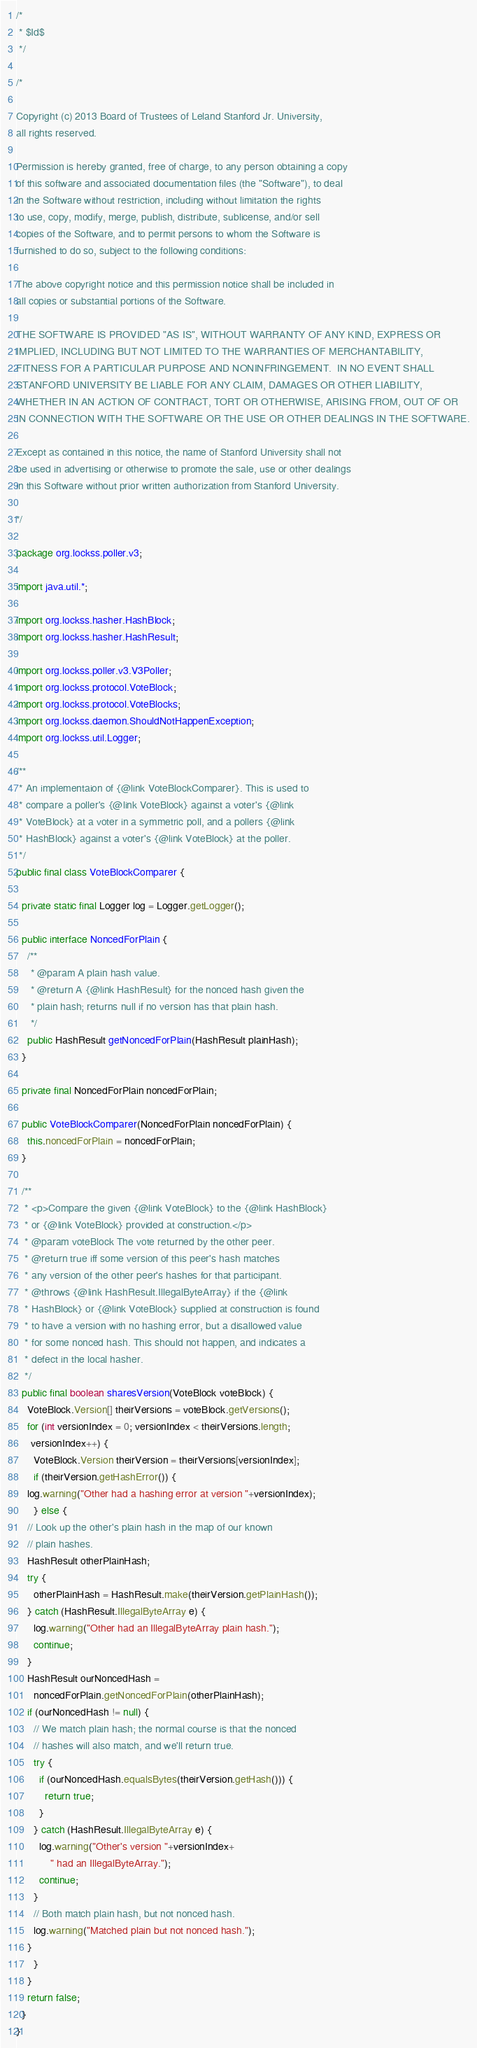<code> <loc_0><loc_0><loc_500><loc_500><_Java_>/*
 * $Id$
 */

/*

Copyright (c) 2013 Board of Trustees of Leland Stanford Jr. University,
all rights reserved.

Permission is hereby granted, free of charge, to any person obtaining a copy
of this software and associated documentation files (the "Software"), to deal
in the Software without restriction, including without limitation the rights
to use, copy, modify, merge, publish, distribute, sublicense, and/or sell
copies of the Software, and to permit persons to whom the Software is
furnished to do so, subject to the following conditions:

The above copyright notice and this permission notice shall be included in
all copies or substantial portions of the Software.

THE SOFTWARE IS PROVIDED "AS IS", WITHOUT WARRANTY OF ANY KIND, EXPRESS OR
IMPLIED, INCLUDING BUT NOT LIMITED TO THE WARRANTIES OF MERCHANTABILITY,
FITNESS FOR A PARTICULAR PURPOSE AND NONINFRINGEMENT.  IN NO EVENT SHALL
STANFORD UNIVERSITY BE LIABLE FOR ANY CLAIM, DAMAGES OR OTHER LIABILITY,
WHETHER IN AN ACTION OF CONTRACT, TORT OR OTHERWISE, ARISING FROM, OUT OF OR
IN CONNECTION WITH THE SOFTWARE OR THE USE OR OTHER DEALINGS IN THE SOFTWARE.

Except as contained in this notice, the name of Stanford University shall not
be used in advertising or otherwise to promote the sale, use or other dealings
in this Software without prior written authorization from Stanford University.

*/

package org.lockss.poller.v3;

import java.util.*;

import org.lockss.hasher.HashBlock;
import org.lockss.hasher.HashResult;

import org.lockss.poller.v3.V3Poller;
import org.lockss.protocol.VoteBlock;
import org.lockss.protocol.VoteBlocks;
import org.lockss.daemon.ShouldNotHappenException;
import org.lockss.util.Logger;

/**
 * An implementaion of {@link VoteBlockComparer}. This is used to
 * compare a poller's {@link VoteBlock} against a voter's {@link
 * VoteBlock} at a voter in a symmetric poll, and a pollers {@link
 * HashBlock} against a voter's {@link VoteBlock} at the poller.
 */
public final class VoteBlockComparer {

  private static final Logger log = Logger.getLogger();

  public interface NoncedForPlain {
    /**
     * @param A plain hash value.
     * @return A {@link HashResult} for the nonced hash given the
     * plain hash; returns null if no version has that plain hash.
     */
    public HashResult getNoncedForPlain(HashResult plainHash);
  }

  private final NoncedForPlain noncedForPlain;

  public VoteBlockComparer(NoncedForPlain noncedForPlain) {
    this.noncedForPlain = noncedForPlain;
  }

  /**
   * <p>Compare the given {@link VoteBlock} to the {@link HashBlock}
   * or {@link VoteBlock} provided at construction.</p>
   * @param voteBlock The vote returned by the other peer.
   * @return true iff some version of this peer's hash matches
   * any version of the other peer's hashes for that participant.
   * @throws {@link HashResult.IllegalByteArray} if the {@link
   * HashBlock} or {@link VoteBlock} supplied at construction is found
   * to have a version with no hashing error, but a disallowed value
   * for some nonced hash. This should not happen, and indicates a
   * defect in the local hasher.
   */
  public final boolean sharesVersion(VoteBlock voteBlock) {
    VoteBlock.Version[] theirVersions = voteBlock.getVersions();
    for (int versionIndex = 0; versionIndex < theirVersions.length;
	 versionIndex++) {
      VoteBlock.Version theirVersion = theirVersions[versionIndex];
      if (theirVersion.getHashError()) {
	log.warning("Other had a hashing error at version "+versionIndex);
      } else {
	// Look up the other's plain hash in the map of our known
	// plain hashes.
	HashResult otherPlainHash;
	try {
	  otherPlainHash = HashResult.make(theirVersion.getPlainHash());
	} catch (HashResult.IllegalByteArray e) {
	  log.warning("Other had an IllegalByteArray plain hash.");
	  continue;
	}
	HashResult ourNoncedHash =
	  noncedForPlain.getNoncedForPlain(otherPlainHash);
	if (ourNoncedHash != null) {
	  // We match plain hash; the normal course is that the nonced
	  // hashes will also match, and we'll return true.
	  try {
	    if (ourNoncedHash.equalsBytes(theirVersion.getHash())) {
	      return true;
	    }
	  } catch (HashResult.IllegalByteArray e) {
	    log.warning("Other's version "+versionIndex+
			" had an IllegalByteArray.");
	    continue;
	  }
	  // Both match plain hash, but not nonced hash.
	  log.warning("Matched plain but not nonced hash.");
	}
      }
    }
    return false;
  }
}
</code> 